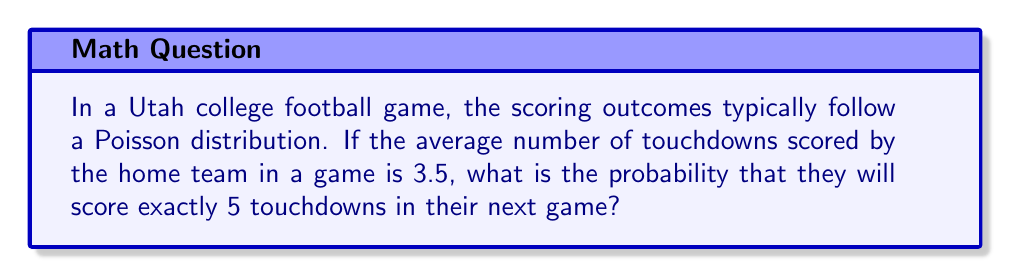Give your solution to this math problem. To solve this problem, we'll use the Poisson distribution formula:

$$P(X = k) = \frac{e^{-\lambda} \lambda^k}{k!}$$

Where:
$P(X = k)$ is the probability of exactly $k$ events occurring
$\lambda$ is the average number of events in the interval
$e$ is Euler's number (approximately 2.71828)
$k!$ is the factorial of $k$

Given:
$\lambda = 3.5$ (average number of touchdowns)
$k = 5$ (number of touchdowns we're calculating the probability for)

Step 1: Plug the values into the formula
$$P(X = 5) = \frac{e^{-3.5} 3.5^5}{5!}$$

Step 2: Calculate $e^{-3.5}$
$$e^{-3.5} \approx 0.0302419$$

Step 3: Calculate $3.5^5$
$$3.5^5 = 525.21875$$

Step 4: Calculate $5!$
$$5! = 5 \times 4 \times 3 \times 2 \times 1 = 120$$

Step 5: Put it all together
$$P(X = 5) = \frac{0.0302419 \times 525.21875}{120}$$

Step 6: Perform the final calculation
$$P(X = 5) \approx 0.1327$$

Therefore, the probability of the home team scoring exactly 5 touchdowns is approximately 0.1327 or 13.27%.
Answer: 0.1327 or 13.27% 